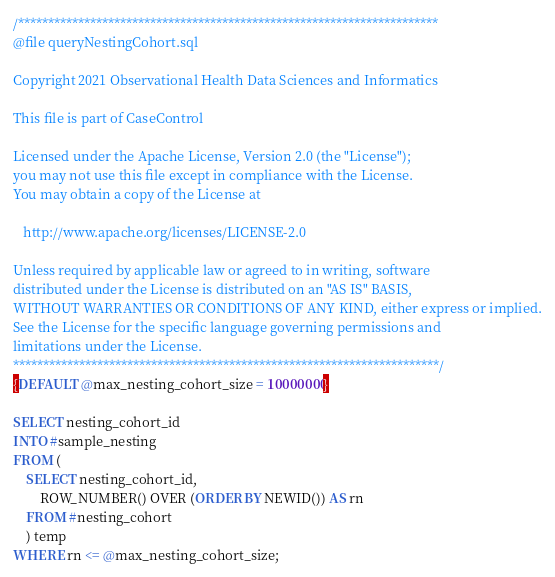<code> <loc_0><loc_0><loc_500><loc_500><_SQL_>/**********************************************************************
@file queryNestingCohort.sql

Copyright 2021 Observational Health Data Sciences and Informatics

This file is part of CaseControl
 
Licensed under the Apache License, Version 2.0 (the "License");
you may not use this file except in compliance with the License.
You may obtain a copy of the License at
 
   http://www.apache.org/licenses/LICENSE-2.0
 
Unless required by applicable law or agreed to in writing, software
distributed under the License is distributed on an "AS IS" BASIS,
WITHOUT WARRANTIES OR CONDITIONS OF ANY KIND, either express or implied.
See the License for the specific language governing permissions and
limitations under the License.
***********************************************************************/
{DEFAULT @max_nesting_cohort_size = 10000000} 

SELECT nesting_cohort_id
INTO #sample_nesting
FROM (
	SELECT nesting_cohort_id,
		ROW_NUMBER() OVER (ORDER BY NEWID()) AS rn
	FROM #nesting_cohort
	) temp
WHERE rn <= @max_nesting_cohort_size;
</code> 